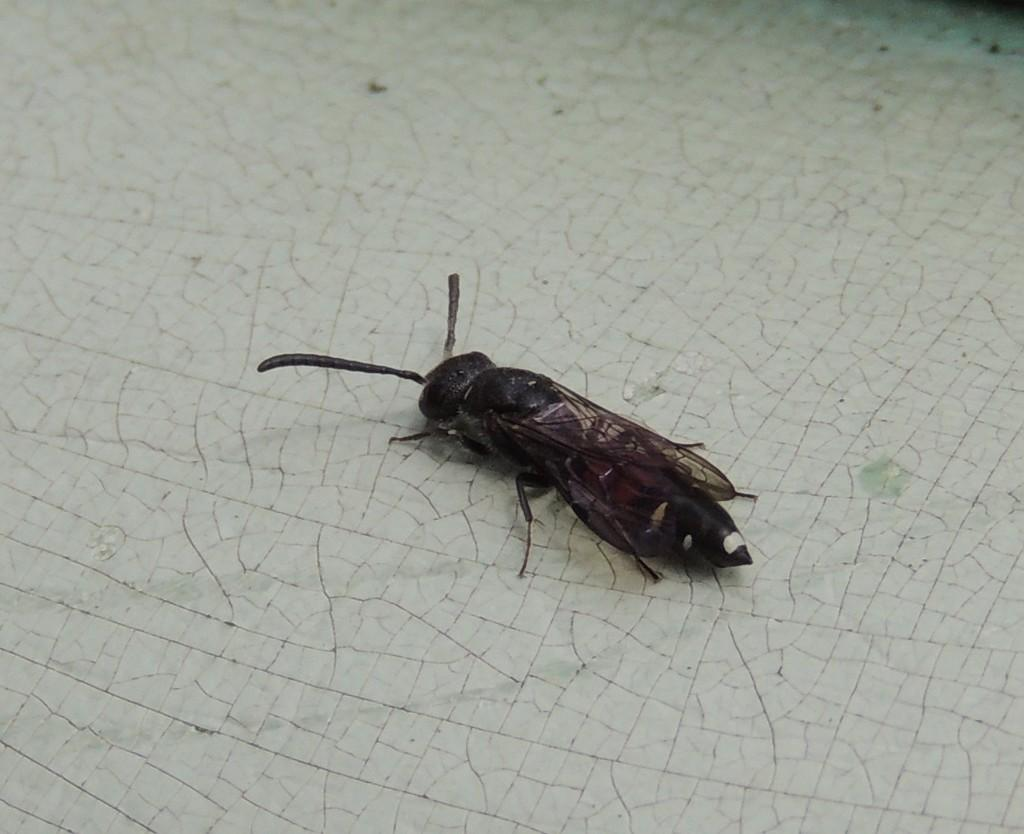What type of insect can be seen in the image? There is a black insect in the image. What is the color of the surface the insect is on? The insect is on a white surface. Can you describe the top part of the image? The top of the image is blurred. What type of guide is the insect holding in the image? There is no guide present in the image, as it only features a black insect on a white surface. 